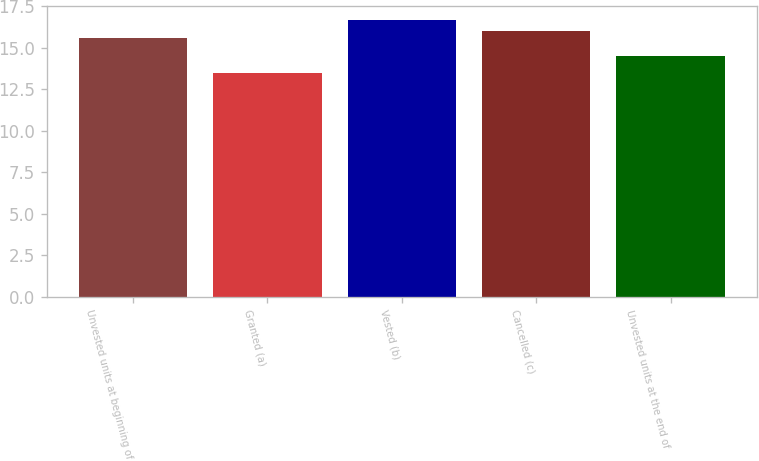Convert chart. <chart><loc_0><loc_0><loc_500><loc_500><bar_chart><fcel>Unvested units at beginning of<fcel>Granted (a)<fcel>Vested (b)<fcel>Cancelled (c)<fcel>Unvested units at the end of<nl><fcel>15.57<fcel>13.47<fcel>16.7<fcel>16.04<fcel>14.54<nl></chart> 